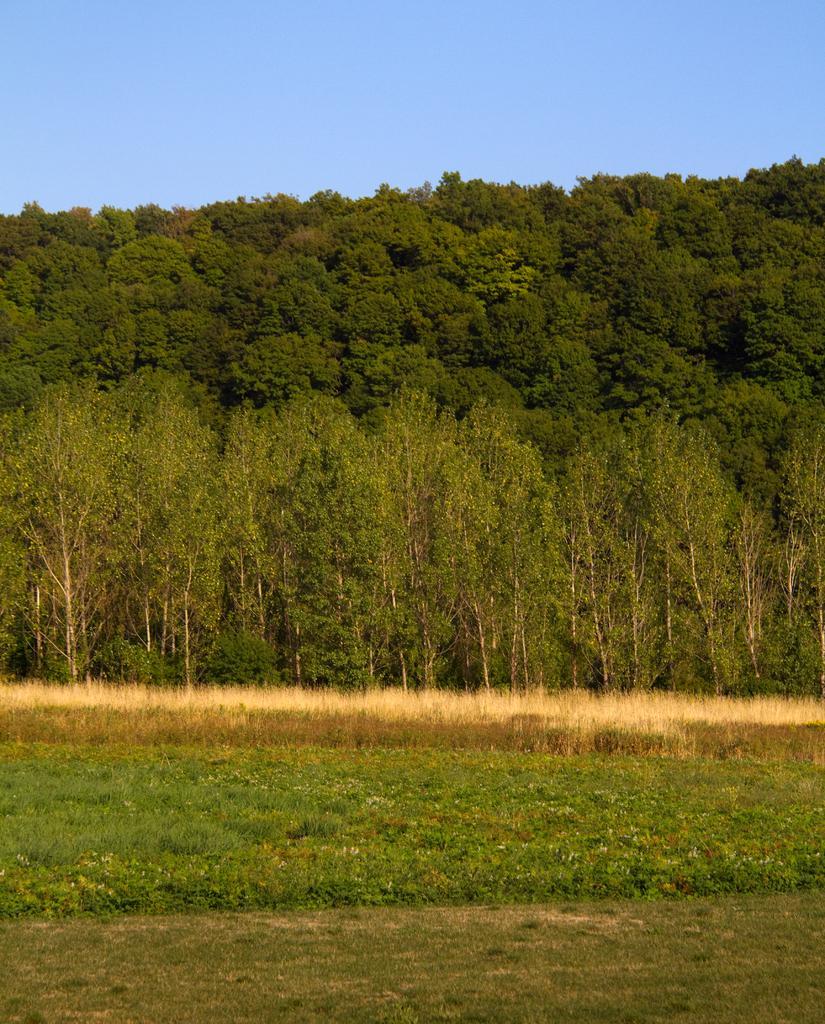Describe this image in one or two sentences. In this picture the ground is greenery and there are few plants in front of it and there are trees in the background. 